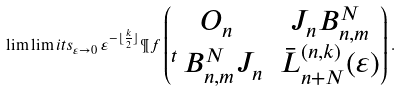Convert formula to latex. <formula><loc_0><loc_0><loc_500><loc_500>\lim \lim i t s _ { \varepsilon \to 0 } \, \varepsilon ^ { - \lfloor \frac { k } { 2 } \rfloor } \P f \begin{pmatrix} O _ { n } & J _ { n } B _ { n , m } ^ { N } \\ ^ { t } \, B _ { n , m } ^ { N } J _ { n } & \bar { L } _ { n + N } ^ { ( n , k ) } ( \varepsilon ) \end{pmatrix} .</formula> 